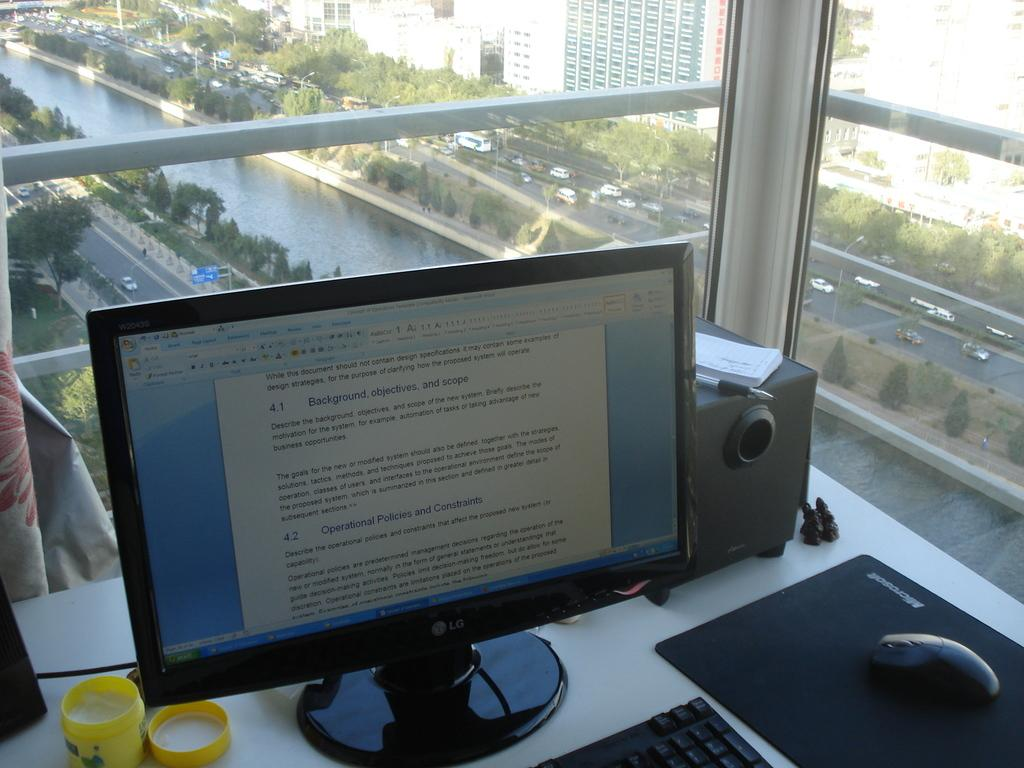Provide a one-sentence caption for the provided image. A computer monitor on a desk displaying a word document of Operational Policies and Constriants. 